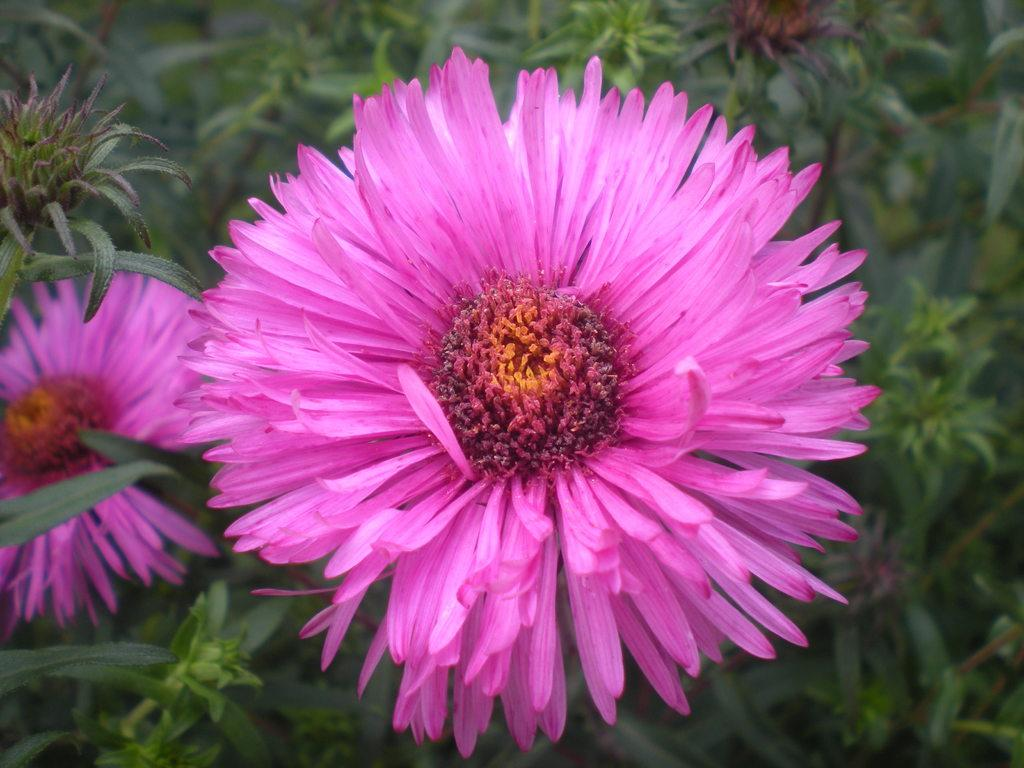What type of flowers can be seen on the plant in the image? There are pink color flowers on a plant in the image. Can you describe the color of the flowers? The flowers are pink in color. What is the main subject of the image? The main subject of the image is a plant with pink flowers. What type of dress is the person wearing while driving the car in the image? There is no person, dress, or car present in the image; it only features a plant with pink flowers. 